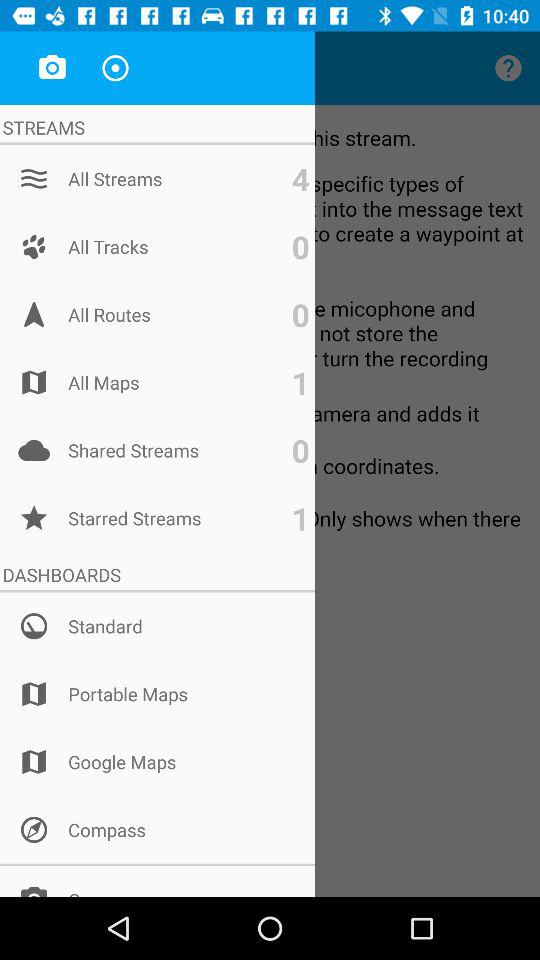What is the mentioned number of items in "All Routes"? The mentioned number of items in "All Routes" is 0. 